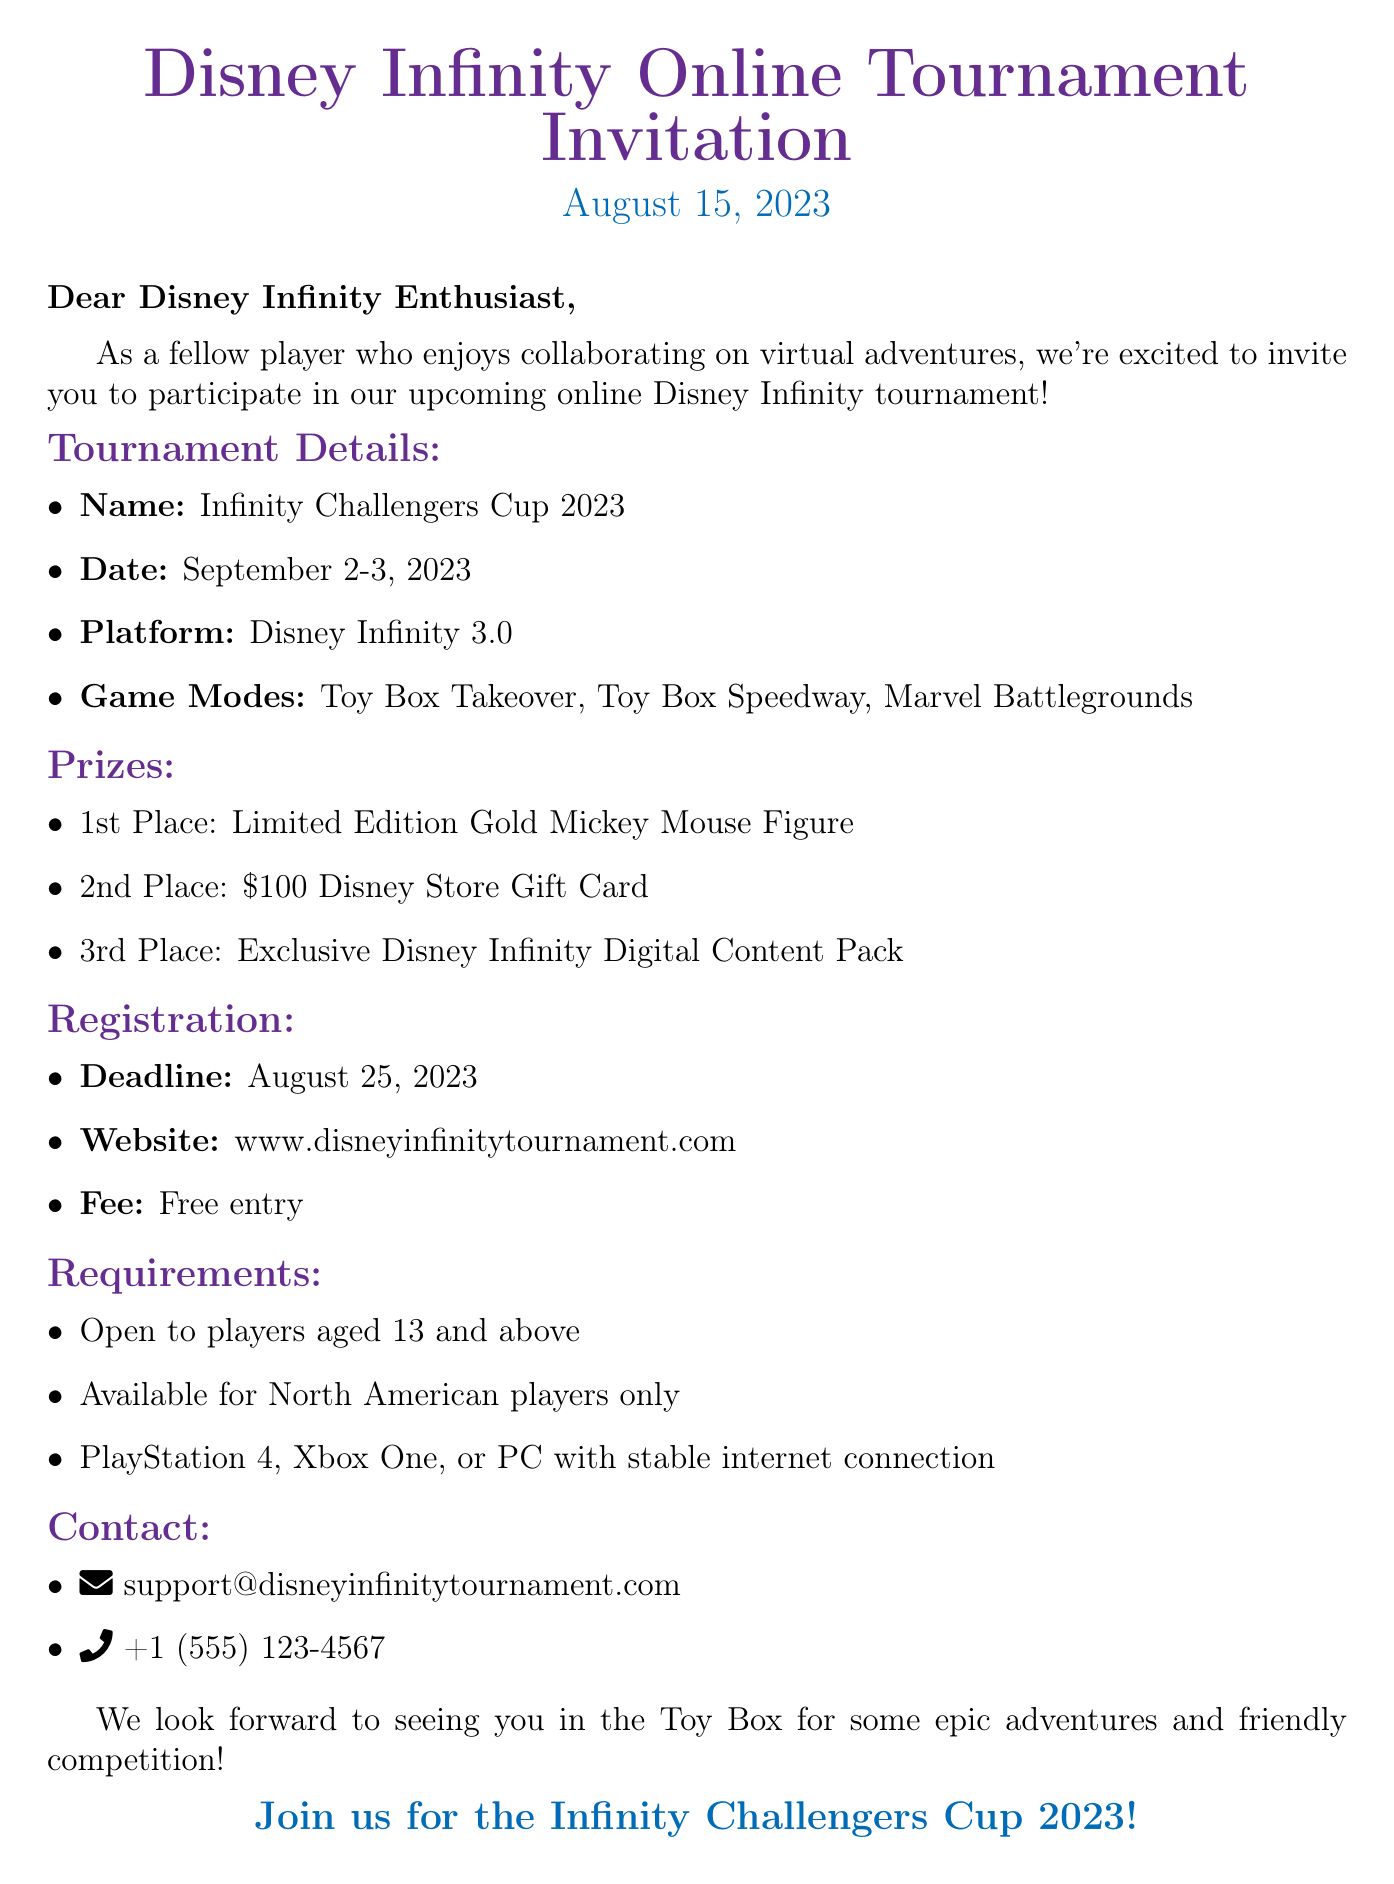What is the name of the tournament? The tournament is called "Infinity Challengers Cup 2023."
Answer: Infinity Challengers Cup 2023 What are the dates of the tournament? The tournament takes place on September 2-3, 2023.
Answer: September 2-3, 2023 What is the prize for the first place? The prize for first place is a "Limited Edition Gold Mickey Mouse Figure."
Answer: Limited Edition Gold Mickey Mouse Figure What is the registration deadline? The registration deadline is August 25, 2023.
Answer: August 25, 2023 What platforms are players allowed to use? Players can use PlayStation 4, Xbox One, or PC with stable internet connection.
Answer: PlayStation 4, Xbox One, or PC How much is the entry fee for the tournament? The entry fee for the tournament is free.
Answer: Free Who can participate in the tournament? The tournament is open to players aged 13 and above.
Answer: Aged 13 and above Which game modes are included in the tournament? The included game modes are Toy Box Takeover, Toy Box Speedway, and Marvel Battlegrounds.
Answer: Toy Box Takeover, Toy Box Speedway, Marvel Battlegrounds What is the contact email for the tournament? The contact email for the tournament is support@disneyinfinitytournament.com.
Answer: support@disneyinfinitytournament.com 